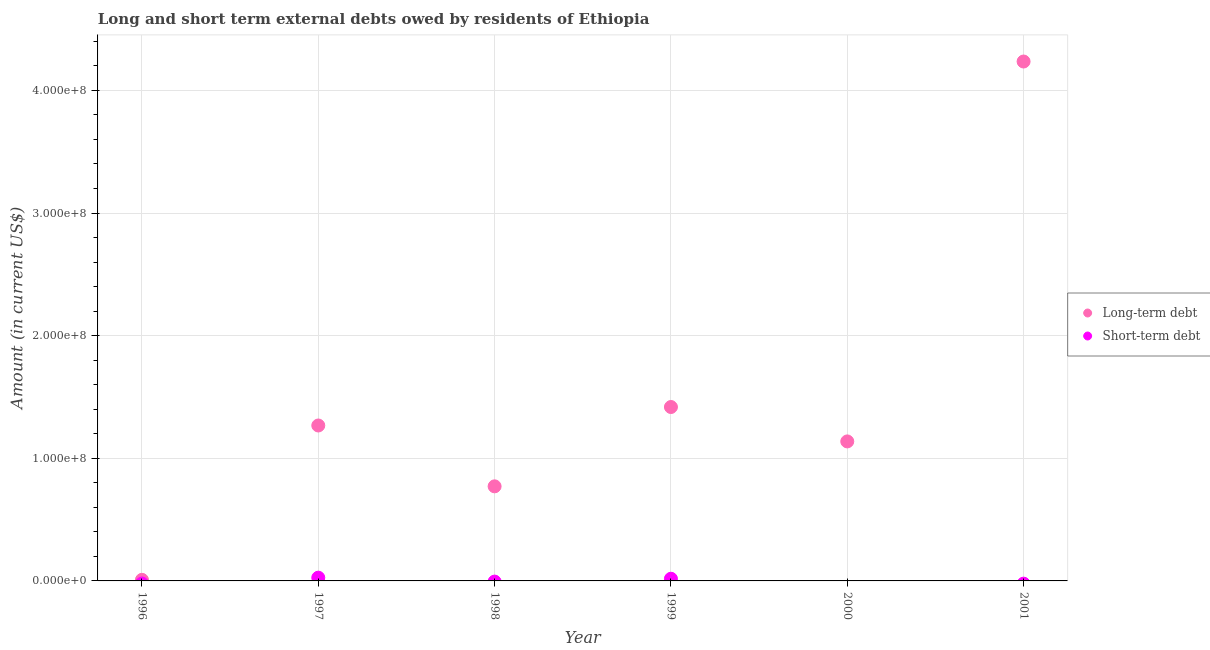Is the number of dotlines equal to the number of legend labels?
Your answer should be compact. No. What is the long-term debts owed by residents in 2001?
Ensure brevity in your answer.  4.24e+08. Across all years, what is the maximum short-term debts owed by residents?
Give a very brief answer. 2.66e+06. In which year was the long-term debts owed by residents maximum?
Your answer should be very brief. 2001. What is the total short-term debts owed by residents in the graph?
Keep it short and to the point. 4.43e+06. What is the difference between the long-term debts owed by residents in 1997 and that in 1998?
Offer a very short reply. 4.96e+07. What is the difference between the short-term debts owed by residents in 1997 and the long-term debts owed by residents in 2001?
Provide a short and direct response. -4.21e+08. What is the average short-term debts owed by residents per year?
Offer a terse response. 7.38e+05. In the year 1999, what is the difference between the long-term debts owed by residents and short-term debts owed by residents?
Offer a terse response. 1.40e+08. In how many years, is the long-term debts owed by residents greater than 420000000 US$?
Make the answer very short. 1. What is the ratio of the long-term debts owed by residents in 1997 to that in 2000?
Your answer should be compact. 1.11. Is the long-term debts owed by residents in 1998 less than that in 2000?
Your response must be concise. Yes. What is the difference between the highest and the second highest long-term debts owed by residents?
Make the answer very short. 2.82e+08. What is the difference between the highest and the lowest short-term debts owed by residents?
Ensure brevity in your answer.  2.66e+06. Does the short-term debts owed by residents monotonically increase over the years?
Offer a terse response. No. Is the long-term debts owed by residents strictly less than the short-term debts owed by residents over the years?
Your response must be concise. No. What is the difference between two consecutive major ticks on the Y-axis?
Give a very brief answer. 1.00e+08. Does the graph contain grids?
Provide a succinct answer. Yes. Where does the legend appear in the graph?
Make the answer very short. Center right. How many legend labels are there?
Provide a short and direct response. 2. What is the title of the graph?
Provide a succinct answer. Long and short term external debts owed by residents of Ethiopia. What is the Amount (in current US$) of Long-term debt in 1996?
Keep it short and to the point. 8.89e+05. What is the Amount (in current US$) in Short-term debt in 1996?
Offer a very short reply. 0. What is the Amount (in current US$) in Long-term debt in 1997?
Provide a short and direct response. 1.27e+08. What is the Amount (in current US$) of Short-term debt in 1997?
Ensure brevity in your answer.  2.66e+06. What is the Amount (in current US$) in Long-term debt in 1998?
Provide a short and direct response. 7.71e+07. What is the Amount (in current US$) in Short-term debt in 1998?
Make the answer very short. 0. What is the Amount (in current US$) in Long-term debt in 1999?
Your answer should be compact. 1.42e+08. What is the Amount (in current US$) in Short-term debt in 1999?
Offer a terse response. 1.77e+06. What is the Amount (in current US$) of Long-term debt in 2000?
Keep it short and to the point. 1.14e+08. What is the Amount (in current US$) of Short-term debt in 2000?
Give a very brief answer. 0. What is the Amount (in current US$) in Long-term debt in 2001?
Provide a succinct answer. 4.24e+08. Across all years, what is the maximum Amount (in current US$) of Long-term debt?
Offer a very short reply. 4.24e+08. Across all years, what is the maximum Amount (in current US$) in Short-term debt?
Your response must be concise. 2.66e+06. Across all years, what is the minimum Amount (in current US$) in Long-term debt?
Offer a very short reply. 8.89e+05. Across all years, what is the minimum Amount (in current US$) of Short-term debt?
Give a very brief answer. 0. What is the total Amount (in current US$) of Long-term debt in the graph?
Your answer should be compact. 8.84e+08. What is the total Amount (in current US$) in Short-term debt in the graph?
Offer a very short reply. 4.43e+06. What is the difference between the Amount (in current US$) in Long-term debt in 1996 and that in 1997?
Your answer should be very brief. -1.26e+08. What is the difference between the Amount (in current US$) in Long-term debt in 1996 and that in 1998?
Provide a short and direct response. -7.62e+07. What is the difference between the Amount (in current US$) of Long-term debt in 1996 and that in 1999?
Your answer should be compact. -1.41e+08. What is the difference between the Amount (in current US$) of Long-term debt in 1996 and that in 2000?
Offer a terse response. -1.13e+08. What is the difference between the Amount (in current US$) of Long-term debt in 1996 and that in 2001?
Give a very brief answer. -4.23e+08. What is the difference between the Amount (in current US$) of Long-term debt in 1997 and that in 1998?
Offer a very short reply. 4.96e+07. What is the difference between the Amount (in current US$) in Long-term debt in 1997 and that in 1999?
Give a very brief answer. -1.51e+07. What is the difference between the Amount (in current US$) in Short-term debt in 1997 and that in 1999?
Offer a very short reply. 8.90e+05. What is the difference between the Amount (in current US$) in Long-term debt in 1997 and that in 2000?
Provide a short and direct response. 1.30e+07. What is the difference between the Amount (in current US$) of Long-term debt in 1997 and that in 2001?
Your answer should be very brief. -2.97e+08. What is the difference between the Amount (in current US$) in Long-term debt in 1998 and that in 1999?
Offer a very short reply. -6.47e+07. What is the difference between the Amount (in current US$) of Long-term debt in 1998 and that in 2000?
Offer a terse response. -3.66e+07. What is the difference between the Amount (in current US$) in Long-term debt in 1998 and that in 2001?
Offer a terse response. -3.46e+08. What is the difference between the Amount (in current US$) in Long-term debt in 1999 and that in 2000?
Provide a succinct answer. 2.81e+07. What is the difference between the Amount (in current US$) of Long-term debt in 1999 and that in 2001?
Give a very brief answer. -2.82e+08. What is the difference between the Amount (in current US$) of Long-term debt in 2000 and that in 2001?
Provide a succinct answer. -3.10e+08. What is the difference between the Amount (in current US$) of Long-term debt in 1996 and the Amount (in current US$) of Short-term debt in 1997?
Make the answer very short. -1.77e+06. What is the difference between the Amount (in current US$) in Long-term debt in 1996 and the Amount (in current US$) in Short-term debt in 1999?
Keep it short and to the point. -8.81e+05. What is the difference between the Amount (in current US$) in Long-term debt in 1997 and the Amount (in current US$) in Short-term debt in 1999?
Your answer should be very brief. 1.25e+08. What is the difference between the Amount (in current US$) in Long-term debt in 1998 and the Amount (in current US$) in Short-term debt in 1999?
Make the answer very short. 7.54e+07. What is the average Amount (in current US$) in Long-term debt per year?
Your response must be concise. 1.47e+08. What is the average Amount (in current US$) of Short-term debt per year?
Provide a short and direct response. 7.38e+05. In the year 1997, what is the difference between the Amount (in current US$) of Long-term debt and Amount (in current US$) of Short-term debt?
Your response must be concise. 1.24e+08. In the year 1999, what is the difference between the Amount (in current US$) in Long-term debt and Amount (in current US$) in Short-term debt?
Your answer should be compact. 1.40e+08. What is the ratio of the Amount (in current US$) of Long-term debt in 1996 to that in 1997?
Give a very brief answer. 0.01. What is the ratio of the Amount (in current US$) in Long-term debt in 1996 to that in 1998?
Give a very brief answer. 0.01. What is the ratio of the Amount (in current US$) in Long-term debt in 1996 to that in 1999?
Ensure brevity in your answer.  0.01. What is the ratio of the Amount (in current US$) of Long-term debt in 1996 to that in 2000?
Offer a very short reply. 0.01. What is the ratio of the Amount (in current US$) of Long-term debt in 1996 to that in 2001?
Offer a terse response. 0. What is the ratio of the Amount (in current US$) of Long-term debt in 1997 to that in 1998?
Provide a short and direct response. 1.64. What is the ratio of the Amount (in current US$) of Long-term debt in 1997 to that in 1999?
Make the answer very short. 0.89. What is the ratio of the Amount (in current US$) in Short-term debt in 1997 to that in 1999?
Ensure brevity in your answer.  1.5. What is the ratio of the Amount (in current US$) of Long-term debt in 1997 to that in 2000?
Make the answer very short. 1.11. What is the ratio of the Amount (in current US$) of Long-term debt in 1997 to that in 2001?
Offer a very short reply. 0.3. What is the ratio of the Amount (in current US$) of Long-term debt in 1998 to that in 1999?
Your response must be concise. 0.54. What is the ratio of the Amount (in current US$) of Long-term debt in 1998 to that in 2000?
Make the answer very short. 0.68. What is the ratio of the Amount (in current US$) in Long-term debt in 1998 to that in 2001?
Provide a succinct answer. 0.18. What is the ratio of the Amount (in current US$) in Long-term debt in 1999 to that in 2000?
Provide a short and direct response. 1.25. What is the ratio of the Amount (in current US$) of Long-term debt in 1999 to that in 2001?
Offer a terse response. 0.33. What is the ratio of the Amount (in current US$) in Long-term debt in 2000 to that in 2001?
Ensure brevity in your answer.  0.27. What is the difference between the highest and the second highest Amount (in current US$) of Long-term debt?
Your answer should be compact. 2.82e+08. What is the difference between the highest and the lowest Amount (in current US$) of Long-term debt?
Provide a short and direct response. 4.23e+08. What is the difference between the highest and the lowest Amount (in current US$) in Short-term debt?
Provide a short and direct response. 2.66e+06. 